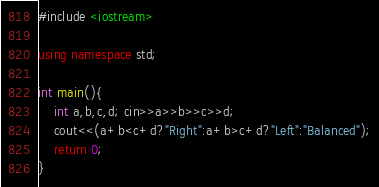Convert code to text. <code><loc_0><loc_0><loc_500><loc_500><_C++_>#include <iostream>

using namespace std;

int main(){
	int a,b,c,d; cin>>a>>b>>c>>d;
	cout<<(a+b<c+d?"Right":a+b>c+d?"Left":"Balanced");
	return 0;
}
</code> 